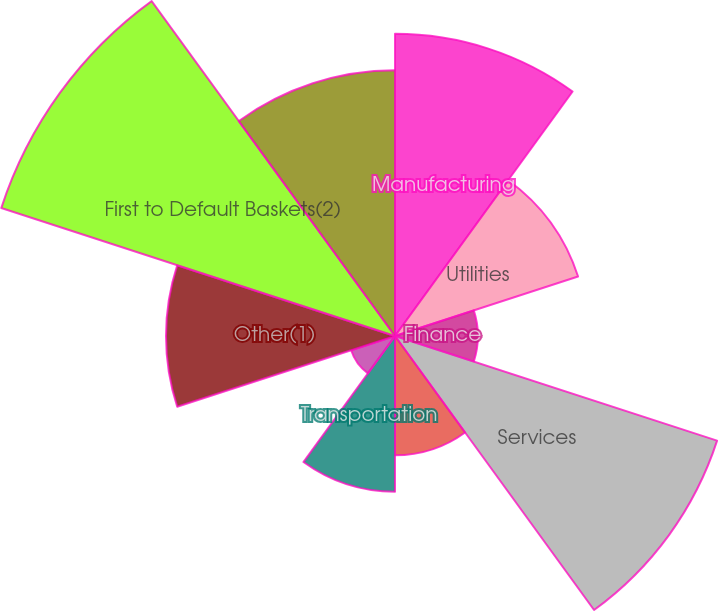<chart> <loc_0><loc_0><loc_500><loc_500><pie_chart><fcel>Manufacturing<fcel>Utilities<fcel>Finance<fcel>Services<fcel>Energy<fcel>Transportation<fcel>Retail and Wholesale<fcel>Other(1)<fcel>First to Default Baskets(2)<fcel>Total Credit Derivatives<nl><fcel>14.08%<fcel>8.97%<fcel>3.86%<fcel>15.78%<fcel>5.56%<fcel>7.26%<fcel>2.15%<fcel>10.67%<fcel>19.29%<fcel>12.38%<nl></chart> 